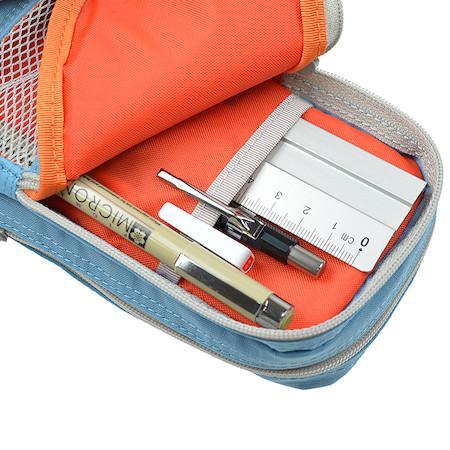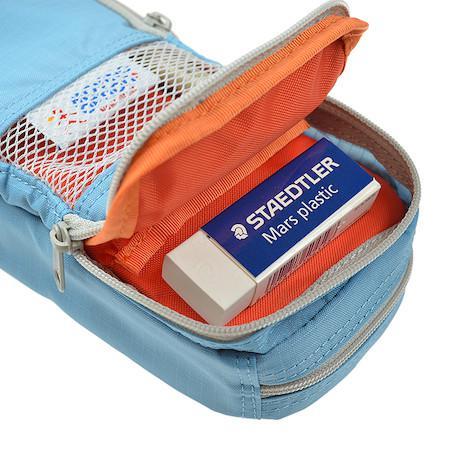The first image is the image on the left, the second image is the image on the right. Analyze the images presented: Is the assertion "At least one of the images has a hand holding the pouch open." valid? Answer yes or no. No. The first image is the image on the left, the second image is the image on the right. Given the left and right images, does the statement "A hand is opening the pencil case in at least one image." hold true? Answer yes or no. No. 